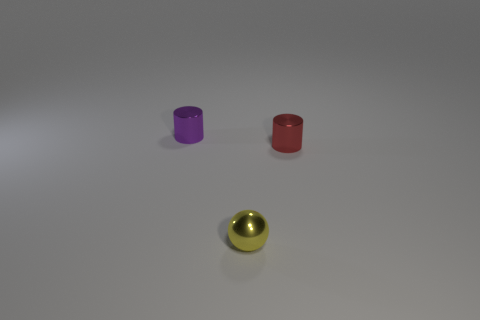Add 1 spheres. How many objects exist? 4 Subtract all purple cylinders. How many cylinders are left? 1 Subtract all balls. How many objects are left? 2 Add 1 tiny shiny objects. How many tiny shiny objects exist? 4 Subtract 0 cyan spheres. How many objects are left? 3 Subtract 1 cylinders. How many cylinders are left? 1 Subtract all brown balls. Subtract all brown blocks. How many balls are left? 1 Subtract all cylinders. Subtract all tiny red metallic cylinders. How many objects are left? 0 Add 1 shiny balls. How many shiny balls are left? 2 